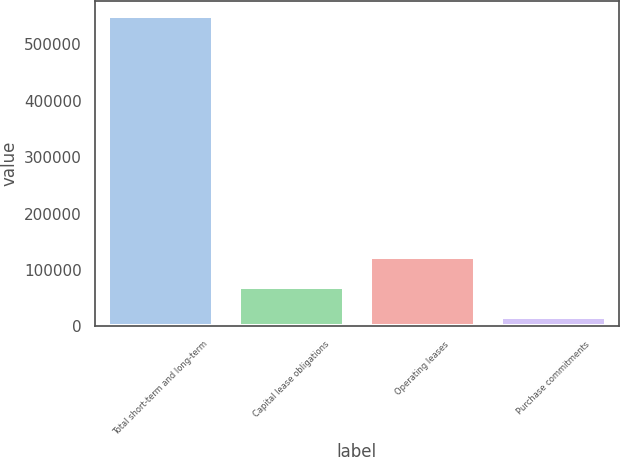Convert chart. <chart><loc_0><loc_0><loc_500><loc_500><bar_chart><fcel>Total short-term and long-term<fcel>Capital lease obligations<fcel>Operating leases<fcel>Purchase commitments<nl><fcel>550000<fcel>69382<fcel>122784<fcel>15980<nl></chart> 